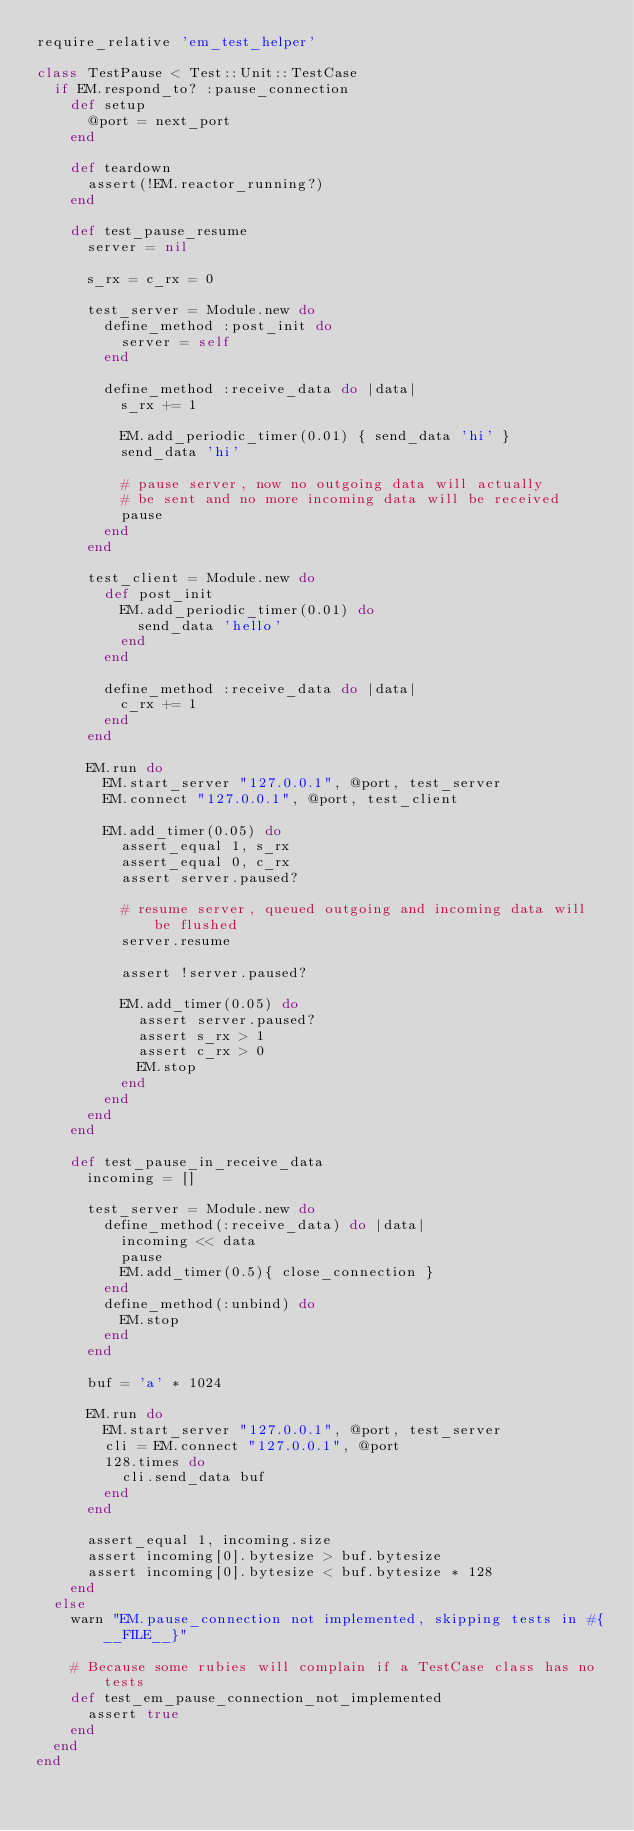Convert code to text. <code><loc_0><loc_0><loc_500><loc_500><_Ruby_>require_relative 'em_test_helper'

class TestPause < Test::Unit::TestCase
  if EM.respond_to? :pause_connection
    def setup
      @port = next_port
    end

    def teardown
      assert(!EM.reactor_running?)
    end

    def test_pause_resume
      server = nil

      s_rx = c_rx = 0

      test_server = Module.new do
        define_method :post_init do
          server = self
        end

        define_method :receive_data do |data|
          s_rx += 1

          EM.add_periodic_timer(0.01) { send_data 'hi' }
          send_data 'hi'

          # pause server, now no outgoing data will actually
          # be sent and no more incoming data will be received
          pause
        end
      end

      test_client = Module.new do
        def post_init
          EM.add_periodic_timer(0.01) do
            send_data 'hello'
          end
        end

        define_method :receive_data do |data|
          c_rx += 1
        end
      end

      EM.run do
        EM.start_server "127.0.0.1", @port, test_server
        EM.connect "127.0.0.1", @port, test_client

        EM.add_timer(0.05) do
          assert_equal 1, s_rx
          assert_equal 0, c_rx
          assert server.paused?

          # resume server, queued outgoing and incoming data will be flushed
          server.resume

          assert !server.paused?

          EM.add_timer(0.05) do
            assert server.paused?
            assert s_rx > 1
            assert c_rx > 0
            EM.stop
          end
        end
      end
    end

    def test_pause_in_receive_data
      incoming = []

      test_server = Module.new do
        define_method(:receive_data) do |data|
          incoming << data
          pause
          EM.add_timer(0.5){ close_connection }
        end
        define_method(:unbind) do
          EM.stop
        end
      end

      buf = 'a' * 1024

      EM.run do
        EM.start_server "127.0.0.1", @port, test_server
        cli = EM.connect "127.0.0.1", @port
        128.times do
          cli.send_data buf
        end
      end

      assert_equal 1, incoming.size
      assert incoming[0].bytesize > buf.bytesize
      assert incoming[0].bytesize < buf.bytesize * 128
    end
  else
    warn "EM.pause_connection not implemented, skipping tests in #{__FILE__}"

    # Because some rubies will complain if a TestCase class has no tests
    def test_em_pause_connection_not_implemented
      assert true
    end
  end
end
</code> 